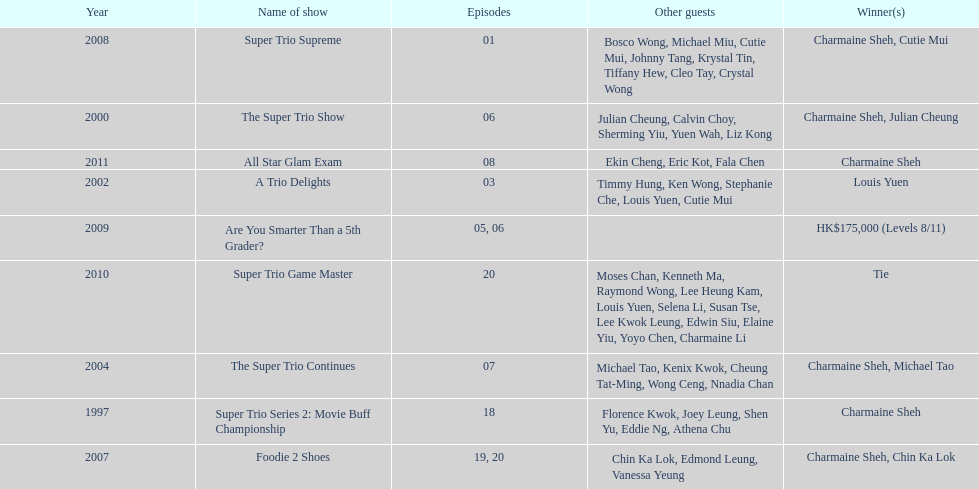How long has it been since chermaine sheh first appeared on a variety show? 17 years. 